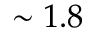Convert formula to latex. <formula><loc_0><loc_0><loc_500><loc_500>\sim 1 . 8</formula> 